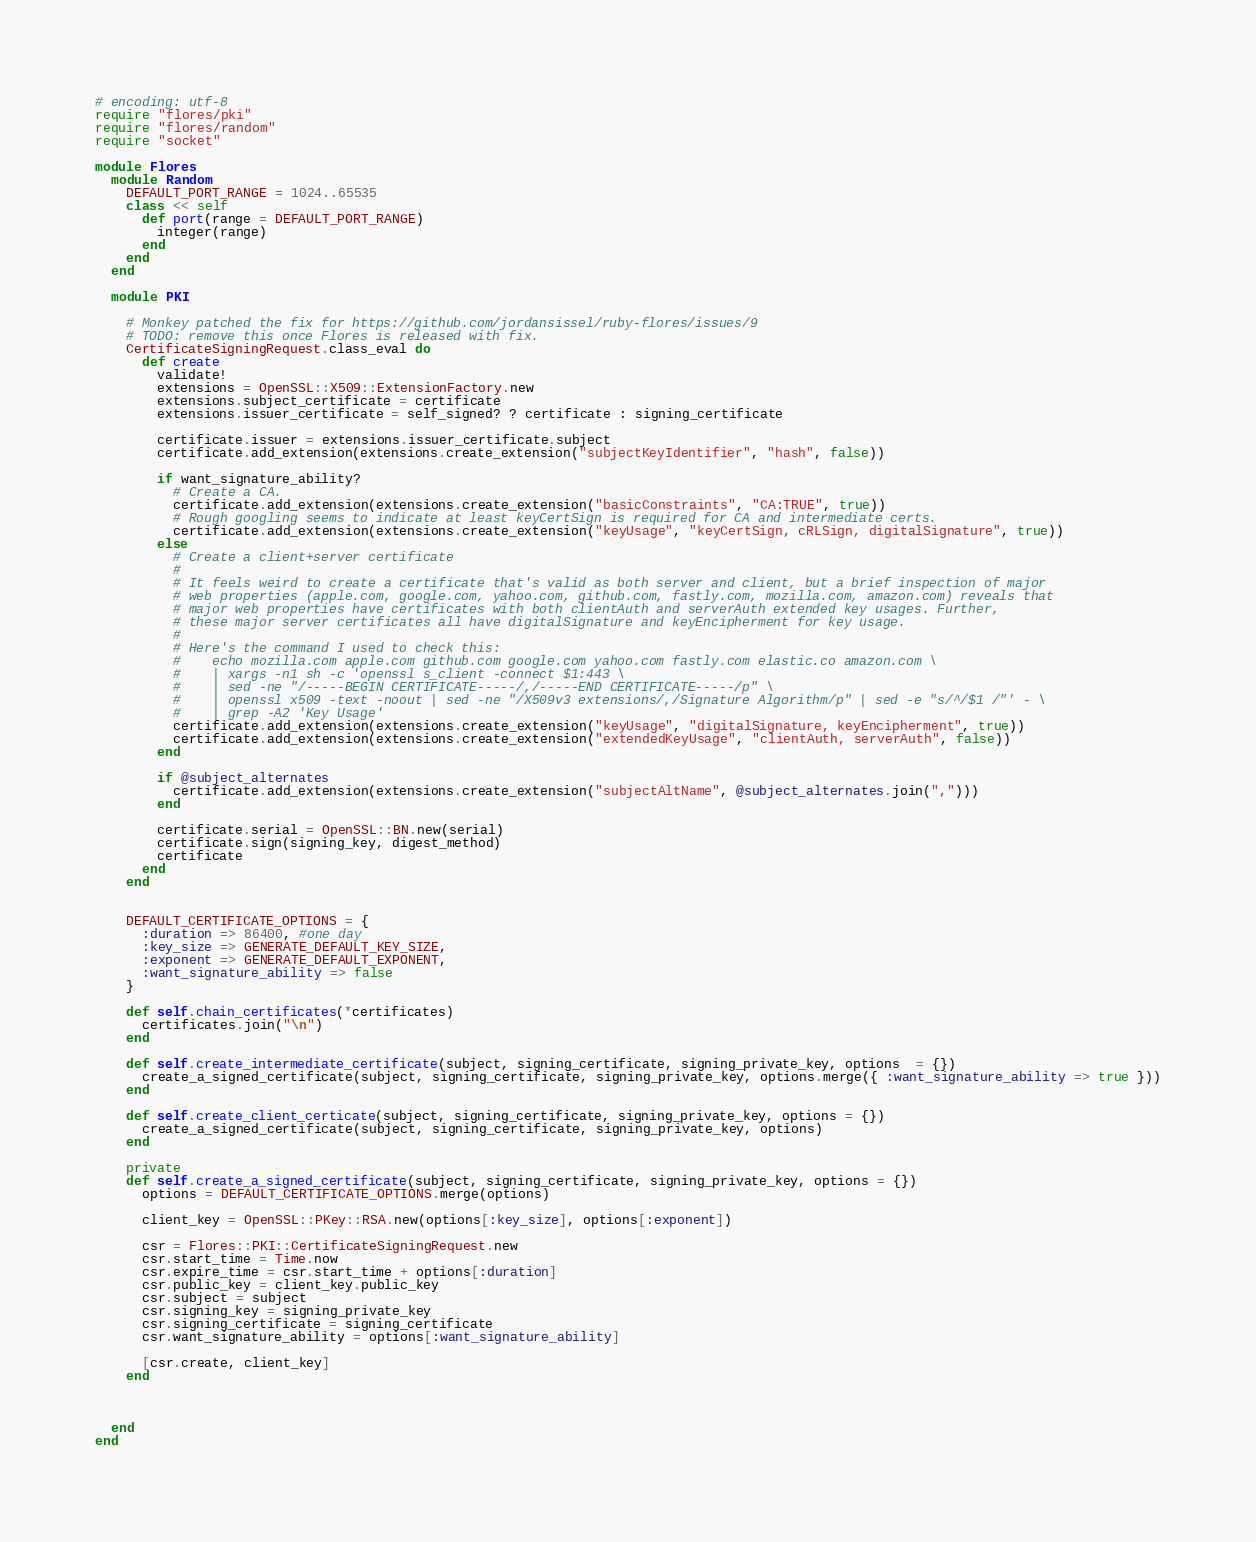Convert code to text. <code><loc_0><loc_0><loc_500><loc_500><_Ruby_># encoding: utf-8
require "flores/pki"
require "flores/random"
require "socket"

module Flores
  module Random
    DEFAULT_PORT_RANGE = 1024..65535
    class << self
      def port(range = DEFAULT_PORT_RANGE)
        integer(range)
      end
    end
  end

  module PKI

    # Monkey patched the fix for https://github.com/jordansissel/ruby-flores/issues/9
    # TODO: remove this once Flores is released with fix.
    CertificateSigningRequest.class_eval do
      def create
        validate!
        extensions = OpenSSL::X509::ExtensionFactory.new
        extensions.subject_certificate = certificate
        extensions.issuer_certificate = self_signed? ? certificate : signing_certificate

        certificate.issuer = extensions.issuer_certificate.subject
        certificate.add_extension(extensions.create_extension("subjectKeyIdentifier", "hash", false))

        if want_signature_ability?
          # Create a CA.
          certificate.add_extension(extensions.create_extension("basicConstraints", "CA:TRUE", true))
          # Rough googling seems to indicate at least keyCertSign is required for CA and intermediate certs.
          certificate.add_extension(extensions.create_extension("keyUsage", "keyCertSign, cRLSign, digitalSignature", true))
        else
          # Create a client+server certificate
          #
          # It feels weird to create a certificate that's valid as both server and client, but a brief inspection of major
          # web properties (apple.com, google.com, yahoo.com, github.com, fastly.com, mozilla.com, amazon.com) reveals that
          # major web properties have certificates with both clientAuth and serverAuth extended key usages. Further,
          # these major server certificates all have digitalSignature and keyEncipherment for key usage.
          #
          # Here's the command I used to check this:
          #    echo mozilla.com apple.com github.com google.com yahoo.com fastly.com elastic.co amazon.com \
          #    | xargs -n1 sh -c 'openssl s_client -connect $1:443 \
          #    | sed -ne "/-----BEGIN CERTIFICATE-----/,/-----END CERTIFICATE-----/p" \
          #    | openssl x509 -text -noout | sed -ne "/X509v3 extensions/,/Signature Algorithm/p" | sed -e "s/^/$1 /"' - \
          #    | grep -A2 'Key Usage'
          certificate.add_extension(extensions.create_extension("keyUsage", "digitalSignature, keyEncipherment", true))
          certificate.add_extension(extensions.create_extension("extendedKeyUsage", "clientAuth, serverAuth", false))
        end

        if @subject_alternates
          certificate.add_extension(extensions.create_extension("subjectAltName", @subject_alternates.join(",")))
        end

        certificate.serial = OpenSSL::BN.new(serial)
        certificate.sign(signing_key, digest_method)
        certificate
      end
    end


    DEFAULT_CERTIFICATE_OPTIONS = {
      :duration => 86400, #one day
      :key_size => GENERATE_DEFAULT_KEY_SIZE, 
      :exponent => GENERATE_DEFAULT_EXPONENT,
      :want_signature_ability => false
    }

    def self.chain_certificates(*certificates)
      certificates.join("\n")
    end

    def self.create_intermediate_certificate(subject, signing_certificate, signing_private_key, options  = {})
      create_a_signed_certificate(subject, signing_certificate, signing_private_key, options.merge({ :want_signature_ability => true }))
    end

    def self.create_client_certicate(subject, signing_certificate, signing_private_key, options = {})
      create_a_signed_certificate(subject, signing_certificate, signing_private_key, options)
    end

    private
    def self.create_a_signed_certificate(subject, signing_certificate, signing_private_key, options = {})
      options = DEFAULT_CERTIFICATE_OPTIONS.merge(options)

      client_key = OpenSSL::PKey::RSA.new(options[:key_size], options[:exponent])

      csr = Flores::PKI::CertificateSigningRequest.new
      csr.start_time = Time.now
      csr.expire_time = csr.start_time + options[:duration]
      csr.public_key = client_key.public_key
      csr.subject = subject
      csr.signing_key = signing_private_key
      csr.signing_certificate = signing_certificate
      csr.want_signature_ability = options[:want_signature_ability]

      [csr.create, client_key]
    end



  end
end

</code> 